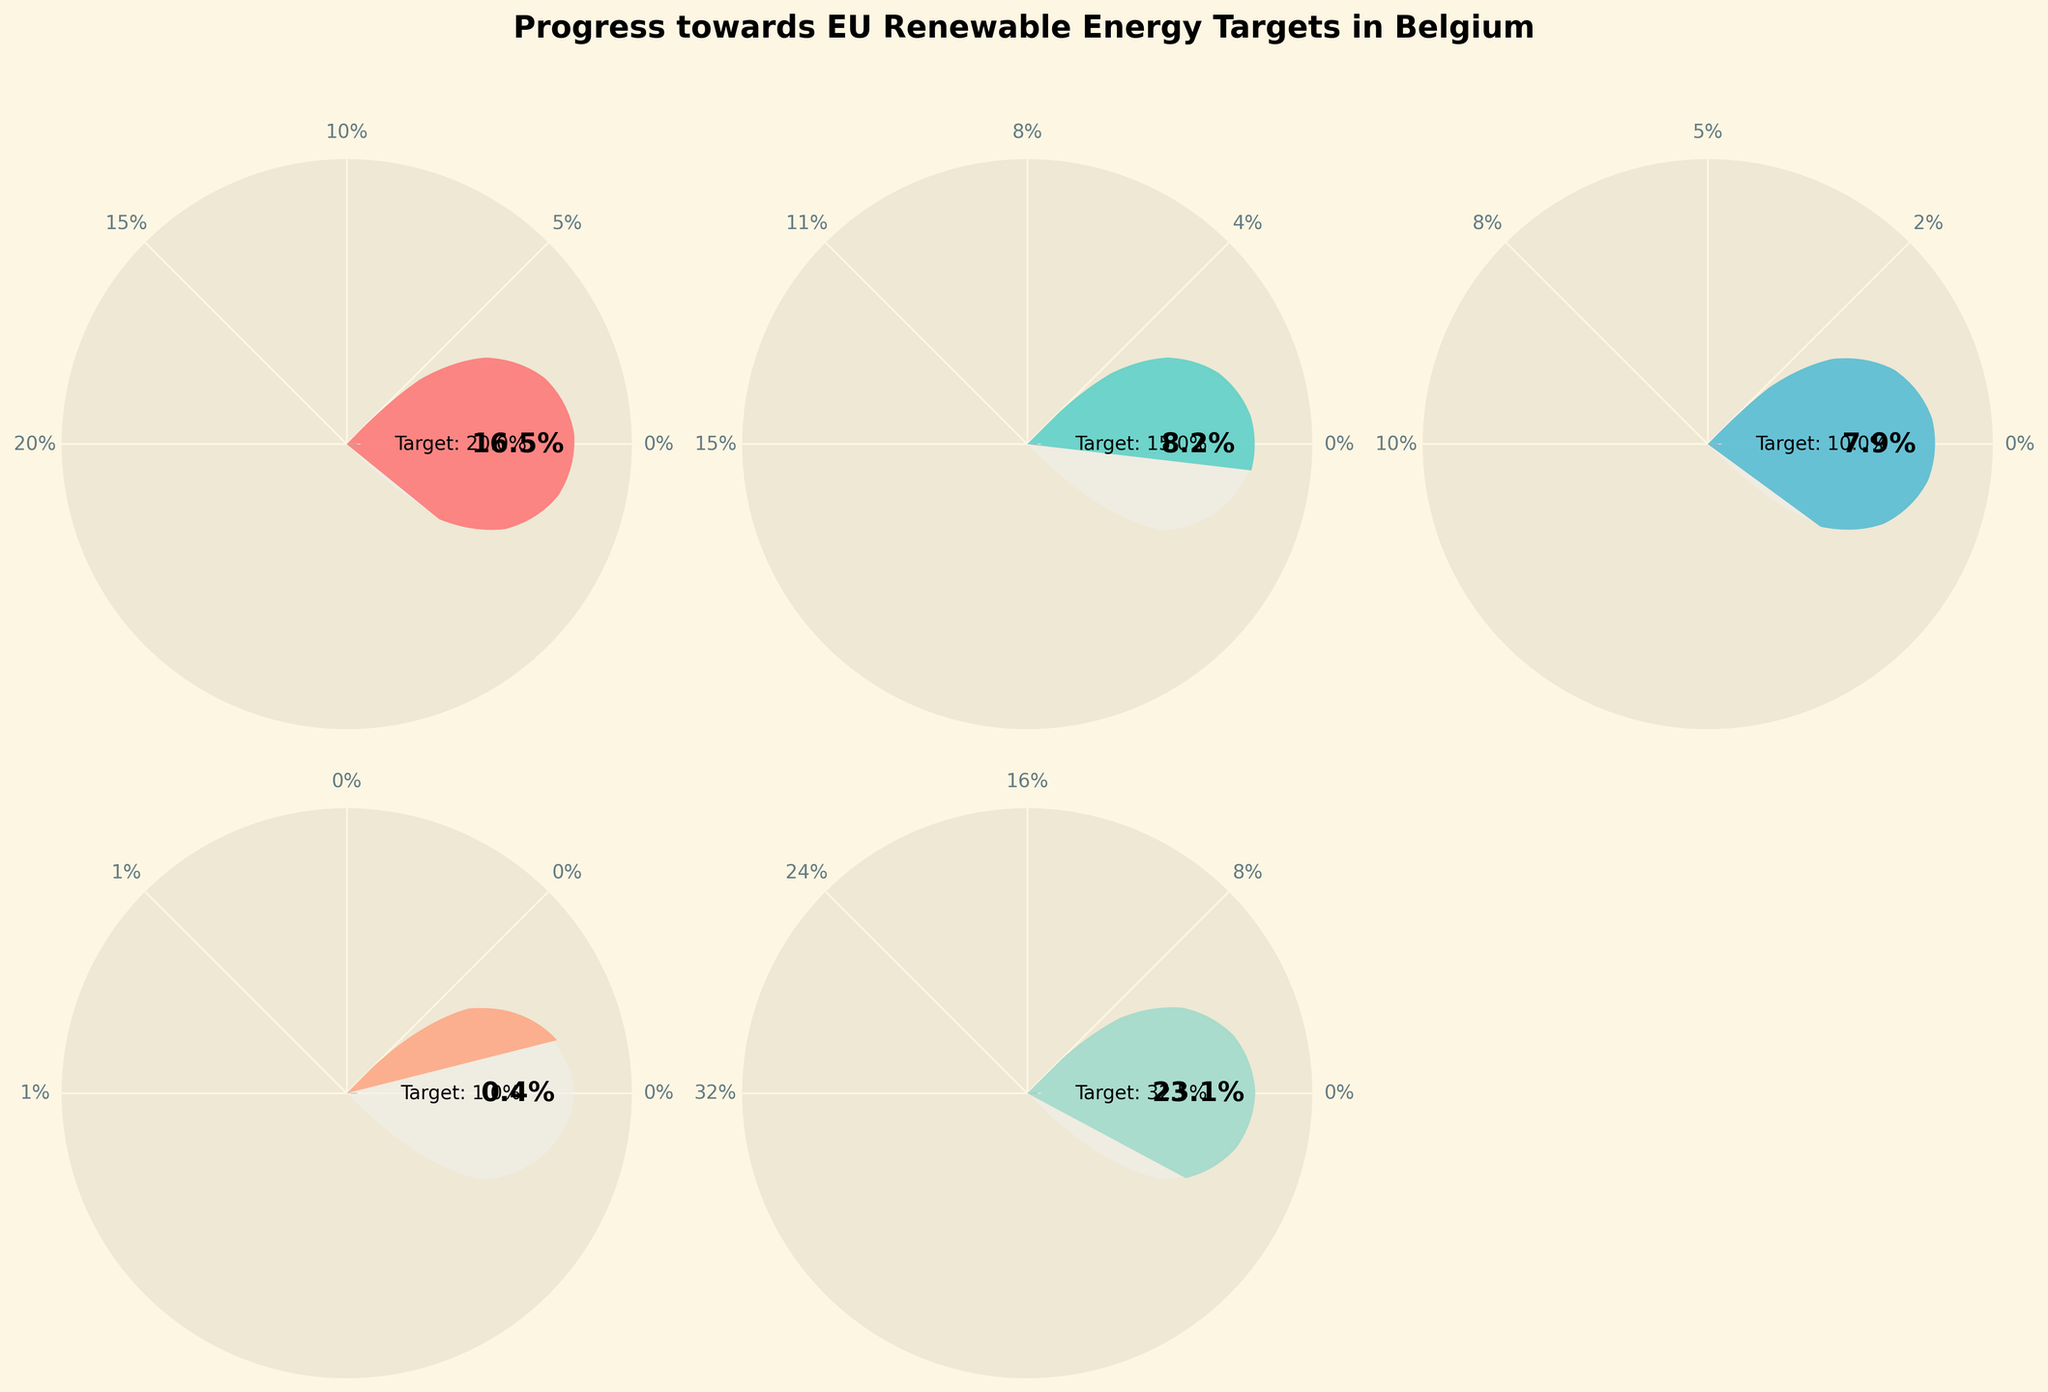How many categories are represented in the gauge charts? There are individual gauge charts for each of the five categories displayed. These are Wind Energy, Solar Energy, Biomass, Hydropower, and Overall Renewable Energy.
Answer: 5 What is the target percentage for Solar Energy? Referring to the Solar Energy gauge chart, the target percentage is displayed at the center of the gauge.
Answer: 15% Which energy source has achieved the highest percentage of progress towards its target? By looking at the progress percentages for each category, Wind Energy has the highest progress percentage of 16.5%.
Answer: Wind Energy How much progress has been made for Biomass in comparison to its target? The progress for Biomass is displayed as 7.9%, and the target is 10%. We need to compare these values to see how much closer it is to the target. 7.9% / 10 = 0.79 or 79%.
Answer: 79% Which category is closest to reaching its target? To determine this, examine the ratio of progress to target for each category. The closest ratio to 1 indicates the category closest to its target. Wind Energy, with a ratio of 16.5/20 = 0.825, is the closest.
Answer: Wind Energy What is the total progress percentage across all categories? Adding up the progress percentages: 16.5 (Wind Energy) + 8.2 (Solar Energy) + 7.9 (Biomass) + 0.4 (Hydropower) + 23.1 (Overall Renewable Energy) = 56.1%.
Answer: 56.1% If the target for Solar Energy was reduced by 2%, what would the new target be? The original target for Solar Energy is 15%. Subtracting 2% from this gives the new target. 15% - 2% = 13%.
Answer: 13% Which energy source has the smallest gap between progress and target? The smallest difference between progress and target must be identified for each category: Wind Energy (20 - 16.5 = 3.5), Solar Energy (15 - 8.2 = 6.8), Biomass (10 - 7.9 = 2.1), Hydropower (1 - 0.4 = 0.6). Hydropower has the smallest gap of 0.6.
Answer: Hydropower 